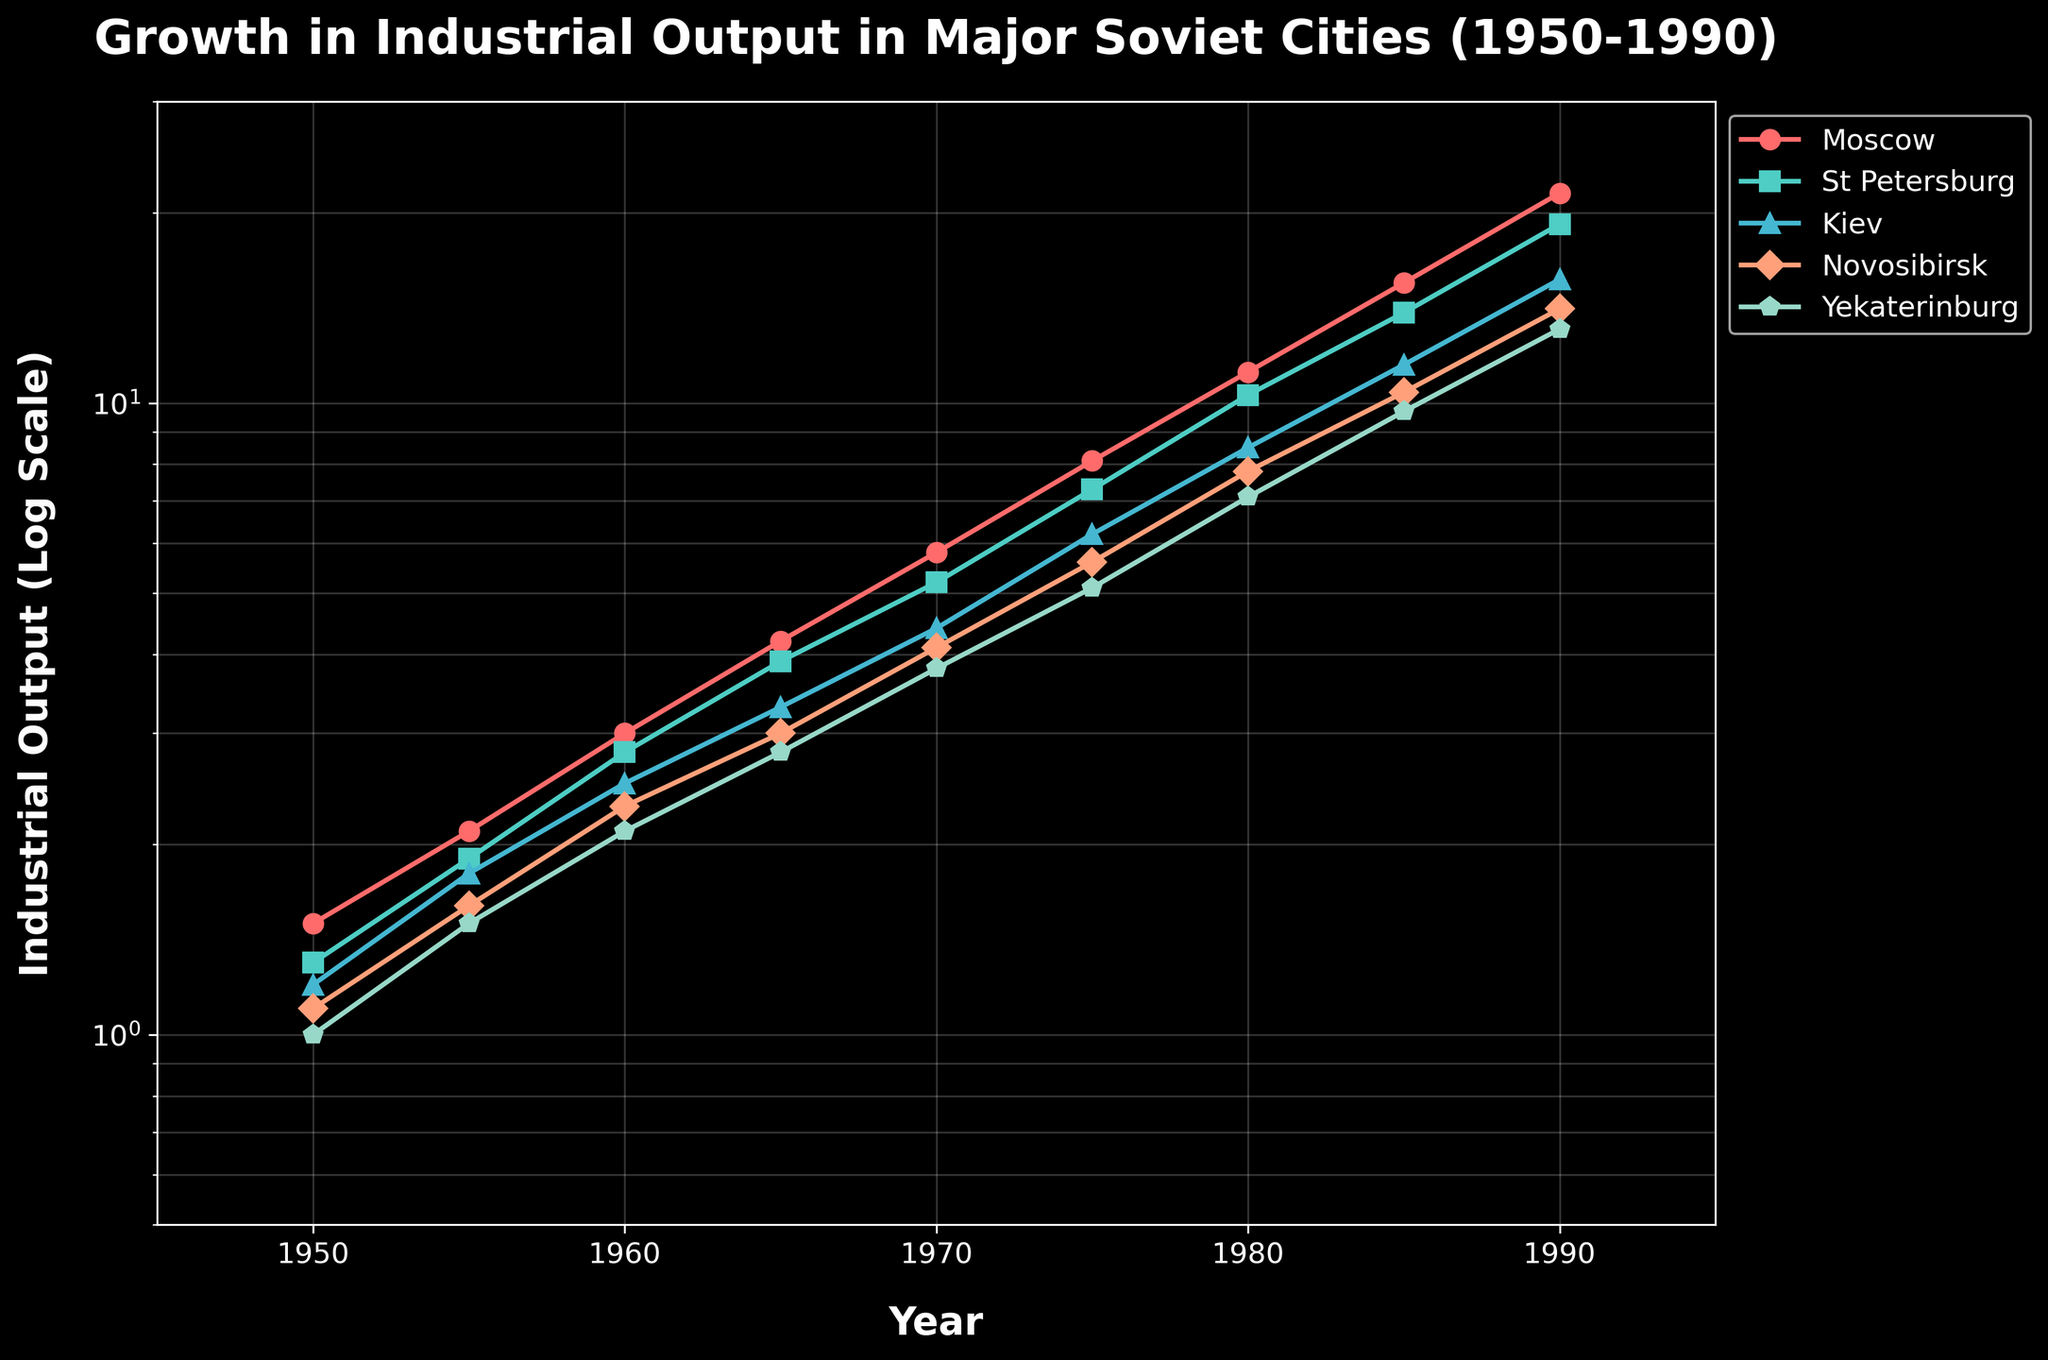what does the title of the plot indicate? The title "Growth in Industrial Output in Major Soviet Cities (1950-1990)" indicates that the plot shows how industrial output grew over time in key Soviet cities between 1950 and 1990.
Answer: Growth in Industrial Output in Major Soviet Cities (1950-1990) Which city had the highest industrial output in 1955? By looking at the y-axis values for the year 1955, Moscow has the highest industrial output with a value of 2.1.
Answer: Moscow Between which years did Moscow see the greatest absolute increase in industrial output? By comparing the differences between each year for Moscow, the greatest absolute increase is between 1985 (15.5) and 1990 (21.5) with an increase of 6.0.
Answer: Between 1985 and 1990 How does the industrial output of Kiev in 1970 compare to that of St. Petersburg in 1965? In 1970, Kiev's industrial output is 4.4. In 1965, St. Petersburg's industrial output is 3.9. Hence, Kiev's industrial output in 1970 is higher than that of St. Petersburg in 1965.
Answer: Kiev's output is higher What is the average industrial output of Yekaterinburg for the entire time period presented? To find the average, sum the industrial output for Yekaterinburg (1.0, 1.5, 2.1, 2.8, 3.8, 5.1, 7.1, 9.7, 13.1) which equals 46.2, and divide by 9, giving an average of approximately 5.13.
Answer: 5.13 Which city shows the slowest initial growth (from 1950 to 1955)? By comparing the growth for each city between 1950 and 1955, Novosibirsk has an increase from 1.1 to 1.6, which is a difference of 0.5—the lowest among the cities listed.
Answer: Novosibirsk At which year do both Novosibirsk and Yekaterinburg have an industrial output value of nearly 7.1? By looking at the values, in 1980 Novosibirsk has an output of 7.8 and Yekaterinburg has an output of 7.1, which is the closest year both cities have approximately the same value.
Answer: 1980 What is the rate of growth for St. Petersburg's industrial output between 1980 and 1985? St. Petersburg’s industrial output grows from 10.3 in 1980 to 13.9 in 1985. The rate of growth can be calculated using the formula ((value_end - value_start) / value_start) * 100). Hence, ((13.9 - 10.3) / 10.3) * 100 ≈ 34.95%.
Answer: 34.95% Which two cities had the closest values of industrial output in 1990? In 1990, St. Petersburg had an output of 19.2 and Kiev had an output of 15.7. The cities with the closest values are Novosibirsk with 14.1 and Yekaterinburg with 13.1.
Answer: Novosibirsk and Yekaterinburg 